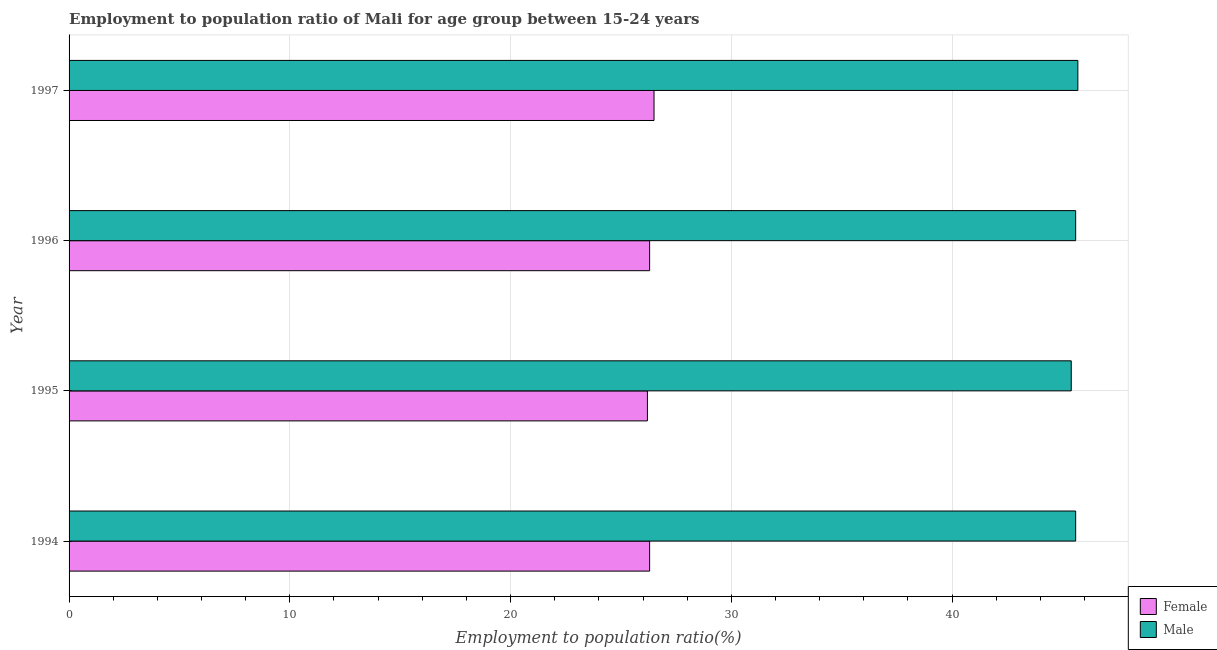How many different coloured bars are there?
Give a very brief answer. 2. Are the number of bars per tick equal to the number of legend labels?
Ensure brevity in your answer.  Yes. How many bars are there on the 4th tick from the top?
Your answer should be compact. 2. What is the label of the 1st group of bars from the top?
Ensure brevity in your answer.  1997. In how many cases, is the number of bars for a given year not equal to the number of legend labels?
Provide a short and direct response. 0. Across all years, what is the maximum employment to population ratio(female)?
Your answer should be compact. 26.5. Across all years, what is the minimum employment to population ratio(male)?
Your answer should be compact. 45.4. In which year was the employment to population ratio(female) maximum?
Offer a very short reply. 1997. What is the total employment to population ratio(male) in the graph?
Offer a terse response. 182.3. What is the difference between the employment to population ratio(female) in 1995 and that in 1996?
Your answer should be compact. -0.1. What is the difference between the employment to population ratio(male) in 1996 and the employment to population ratio(female) in 1994?
Your answer should be very brief. 19.3. What is the average employment to population ratio(male) per year?
Your response must be concise. 45.58. In the year 1995, what is the difference between the employment to population ratio(female) and employment to population ratio(male)?
Offer a terse response. -19.2. Is the employment to population ratio(female) in 1995 less than that in 1997?
Keep it short and to the point. Yes. Is the difference between the employment to population ratio(female) in 1995 and 1996 greater than the difference between the employment to population ratio(male) in 1995 and 1996?
Your answer should be very brief. Yes. In how many years, is the employment to population ratio(male) greater than the average employment to population ratio(male) taken over all years?
Your response must be concise. 3. Is the sum of the employment to population ratio(male) in 1994 and 1997 greater than the maximum employment to population ratio(female) across all years?
Offer a terse response. Yes. What does the 1st bar from the top in 1997 represents?
Offer a very short reply. Male. What does the 1st bar from the bottom in 1995 represents?
Make the answer very short. Female. How many bars are there?
Your answer should be very brief. 8. Are all the bars in the graph horizontal?
Offer a terse response. Yes. How many years are there in the graph?
Provide a succinct answer. 4. Are the values on the major ticks of X-axis written in scientific E-notation?
Make the answer very short. No. Does the graph contain grids?
Provide a succinct answer. Yes. What is the title of the graph?
Your answer should be compact. Employment to population ratio of Mali for age group between 15-24 years. What is the Employment to population ratio(%) in Female in 1994?
Ensure brevity in your answer.  26.3. What is the Employment to population ratio(%) of Male in 1994?
Provide a succinct answer. 45.6. What is the Employment to population ratio(%) of Female in 1995?
Your answer should be very brief. 26.2. What is the Employment to population ratio(%) of Male in 1995?
Your answer should be compact. 45.4. What is the Employment to population ratio(%) in Female in 1996?
Provide a succinct answer. 26.3. What is the Employment to population ratio(%) in Male in 1996?
Make the answer very short. 45.6. What is the Employment to population ratio(%) of Female in 1997?
Make the answer very short. 26.5. What is the Employment to population ratio(%) in Male in 1997?
Make the answer very short. 45.7. Across all years, what is the maximum Employment to population ratio(%) in Female?
Provide a succinct answer. 26.5. Across all years, what is the maximum Employment to population ratio(%) in Male?
Provide a succinct answer. 45.7. Across all years, what is the minimum Employment to population ratio(%) in Female?
Keep it short and to the point. 26.2. Across all years, what is the minimum Employment to population ratio(%) of Male?
Provide a short and direct response. 45.4. What is the total Employment to population ratio(%) of Female in the graph?
Offer a terse response. 105.3. What is the total Employment to population ratio(%) of Male in the graph?
Your answer should be compact. 182.3. What is the difference between the Employment to population ratio(%) of Female in 1994 and that in 1997?
Keep it short and to the point. -0.2. What is the difference between the Employment to population ratio(%) in Male in 1994 and that in 1997?
Keep it short and to the point. -0.1. What is the difference between the Employment to population ratio(%) of Female in 1995 and that in 1996?
Provide a succinct answer. -0.1. What is the difference between the Employment to population ratio(%) of Male in 1995 and that in 1996?
Keep it short and to the point. -0.2. What is the difference between the Employment to population ratio(%) in Female in 1996 and that in 1997?
Your answer should be very brief. -0.2. What is the difference between the Employment to population ratio(%) of Male in 1996 and that in 1997?
Your answer should be compact. -0.1. What is the difference between the Employment to population ratio(%) of Female in 1994 and the Employment to population ratio(%) of Male in 1995?
Your response must be concise. -19.1. What is the difference between the Employment to population ratio(%) of Female in 1994 and the Employment to population ratio(%) of Male in 1996?
Make the answer very short. -19.3. What is the difference between the Employment to population ratio(%) in Female in 1994 and the Employment to population ratio(%) in Male in 1997?
Your response must be concise. -19.4. What is the difference between the Employment to population ratio(%) in Female in 1995 and the Employment to population ratio(%) in Male in 1996?
Give a very brief answer. -19.4. What is the difference between the Employment to population ratio(%) of Female in 1995 and the Employment to population ratio(%) of Male in 1997?
Ensure brevity in your answer.  -19.5. What is the difference between the Employment to population ratio(%) of Female in 1996 and the Employment to population ratio(%) of Male in 1997?
Your response must be concise. -19.4. What is the average Employment to population ratio(%) in Female per year?
Provide a short and direct response. 26.32. What is the average Employment to population ratio(%) of Male per year?
Ensure brevity in your answer.  45.58. In the year 1994, what is the difference between the Employment to population ratio(%) in Female and Employment to population ratio(%) in Male?
Ensure brevity in your answer.  -19.3. In the year 1995, what is the difference between the Employment to population ratio(%) in Female and Employment to population ratio(%) in Male?
Offer a very short reply. -19.2. In the year 1996, what is the difference between the Employment to population ratio(%) of Female and Employment to population ratio(%) of Male?
Offer a very short reply. -19.3. In the year 1997, what is the difference between the Employment to population ratio(%) of Female and Employment to population ratio(%) of Male?
Your answer should be compact. -19.2. What is the ratio of the Employment to population ratio(%) of Male in 1994 to that in 1995?
Provide a succinct answer. 1. What is the ratio of the Employment to population ratio(%) of Female in 1995 to that in 1997?
Make the answer very short. 0.99. What is the ratio of the Employment to population ratio(%) of Female in 1996 to that in 1997?
Your response must be concise. 0.99. What is the ratio of the Employment to population ratio(%) of Male in 1996 to that in 1997?
Your response must be concise. 1. What is the difference between the highest and the second highest Employment to population ratio(%) of Female?
Ensure brevity in your answer.  0.2. 